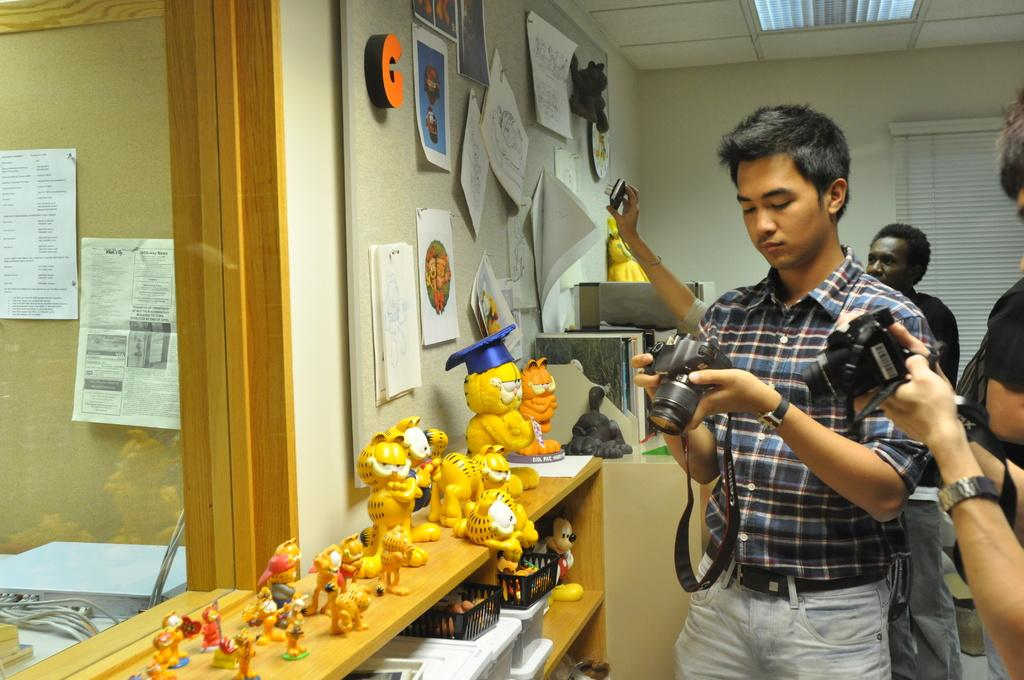<image>
Offer a succinct explanation of the picture presented. The letter C is on a wall with people with cameras nearby. 